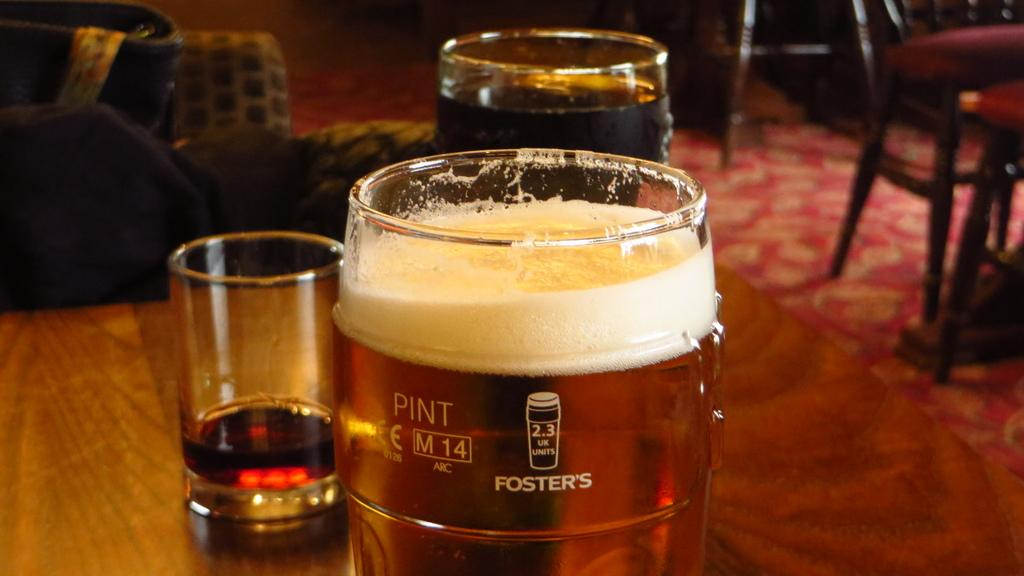<image>
Offer a succinct explanation of the picture presented. A glass that says Foster's on it is full with beer. 